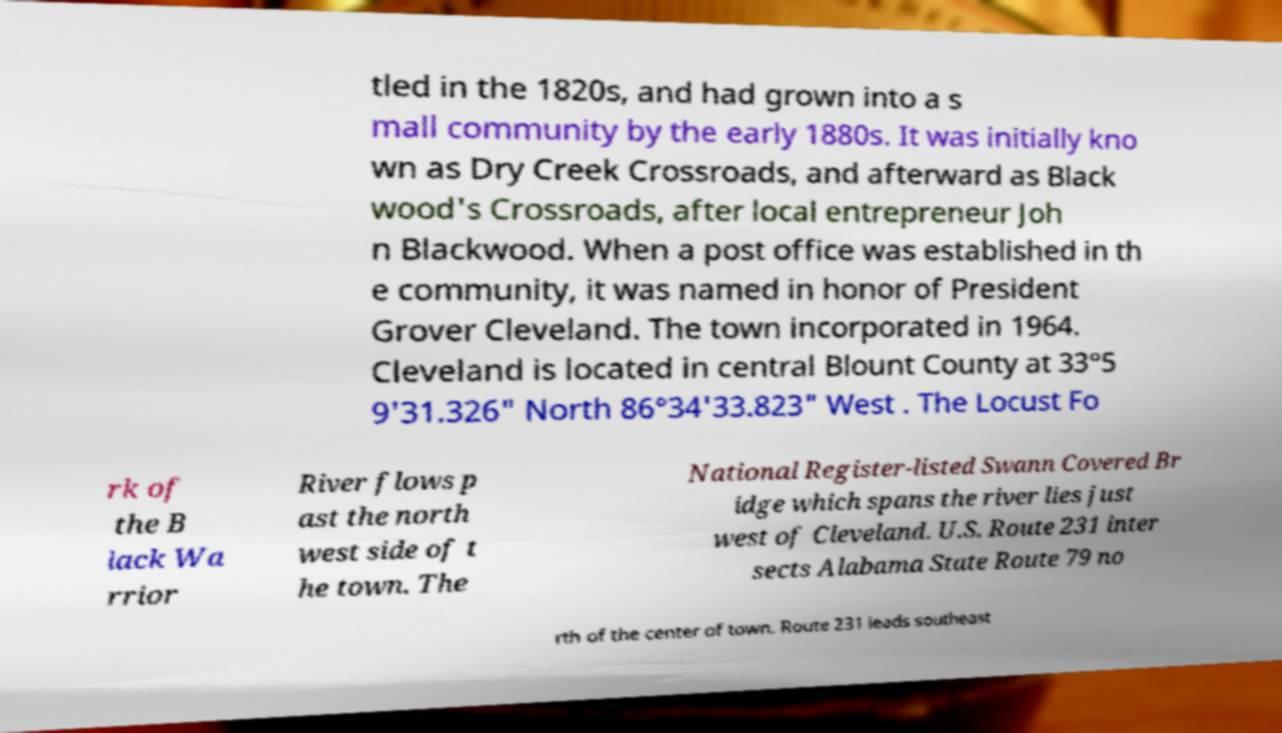Could you extract and type out the text from this image? tled in the 1820s, and had grown into a s mall community by the early 1880s. It was initially kno wn as Dry Creek Crossroads, and afterward as Black wood's Crossroads, after local entrepreneur Joh n Blackwood. When a post office was established in th e community, it was named in honor of President Grover Cleveland. The town incorporated in 1964. Cleveland is located in central Blount County at 33°5 9'31.326" North 86°34'33.823" West . The Locust Fo rk of the B lack Wa rrior River flows p ast the north west side of t he town. The National Register-listed Swann Covered Br idge which spans the river lies just west of Cleveland. U.S. Route 231 inter sects Alabama State Route 79 no rth of the center of town. Route 231 leads southeast 